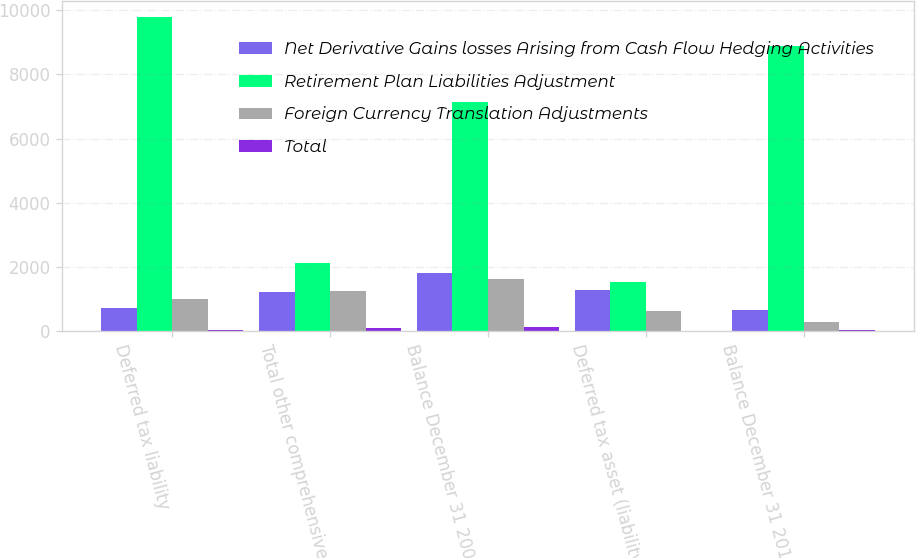<chart> <loc_0><loc_0><loc_500><loc_500><stacked_bar_chart><ecel><fcel>Deferred tax liability<fcel>Total other comprehensive<fcel>Balance December 31 2009 net<fcel>Deferred tax asset (liability)<fcel>Balance December 31 2010 net<nl><fcel>Net Derivative Gains losses Arising from Cash Flow Hedging Activities<fcel>724<fcel>1229<fcel>1810<fcel>1293<fcel>659<nl><fcel>Retirement Plan Liabilities Adjustment<fcel>9802<fcel>2111<fcel>7145<fcel>1529<fcel>8888<nl><fcel>Foreign Currency Translation Adjustments<fcel>1005<fcel>1252<fcel>1630<fcel>621<fcel>298<nl><fcel>Total<fcel>32<fcel>94<fcel>128<fcel>17<fcel>34<nl></chart> 